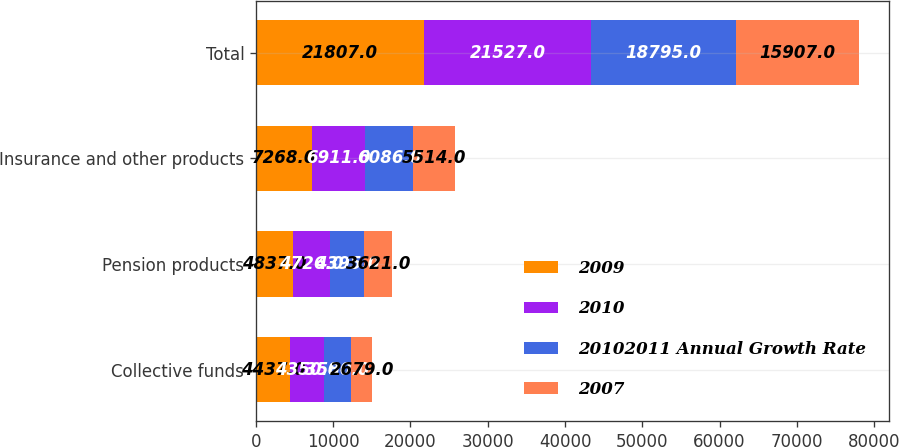<chart> <loc_0><loc_0><loc_500><loc_500><stacked_bar_chart><ecel><fcel>Collective funds<fcel>Pension products<fcel>Insurance and other products<fcel>Total<nl><fcel>2009<fcel>4437<fcel>4837<fcel>7268<fcel>21807<nl><fcel>2010<fcel>4350<fcel>4726<fcel>6911<fcel>21527<nl><fcel>20102011 Annual Growth Rate<fcel>3580<fcel>4395<fcel>6086<fcel>18795<nl><fcel>2007<fcel>2679<fcel>3621<fcel>5514<fcel>15907<nl></chart> 